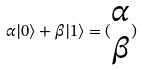Convert formula to latex. <formula><loc_0><loc_0><loc_500><loc_500>\alpha | 0 \rangle + \beta | 1 \rangle = ( \begin{matrix} \alpha \\ \beta \end{matrix} )</formula> 